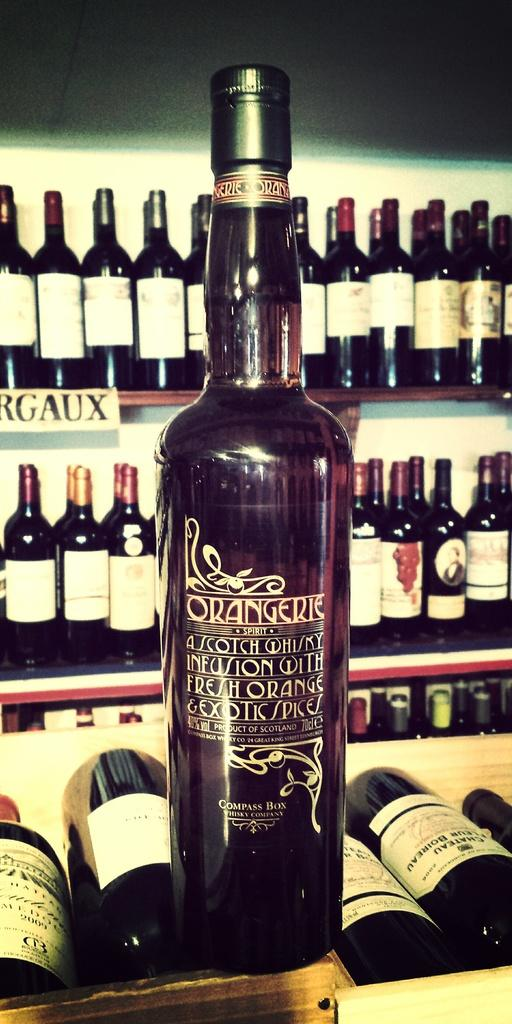<image>
Describe the image concisely. A bottle of wine that has the word Orangerie on it. 